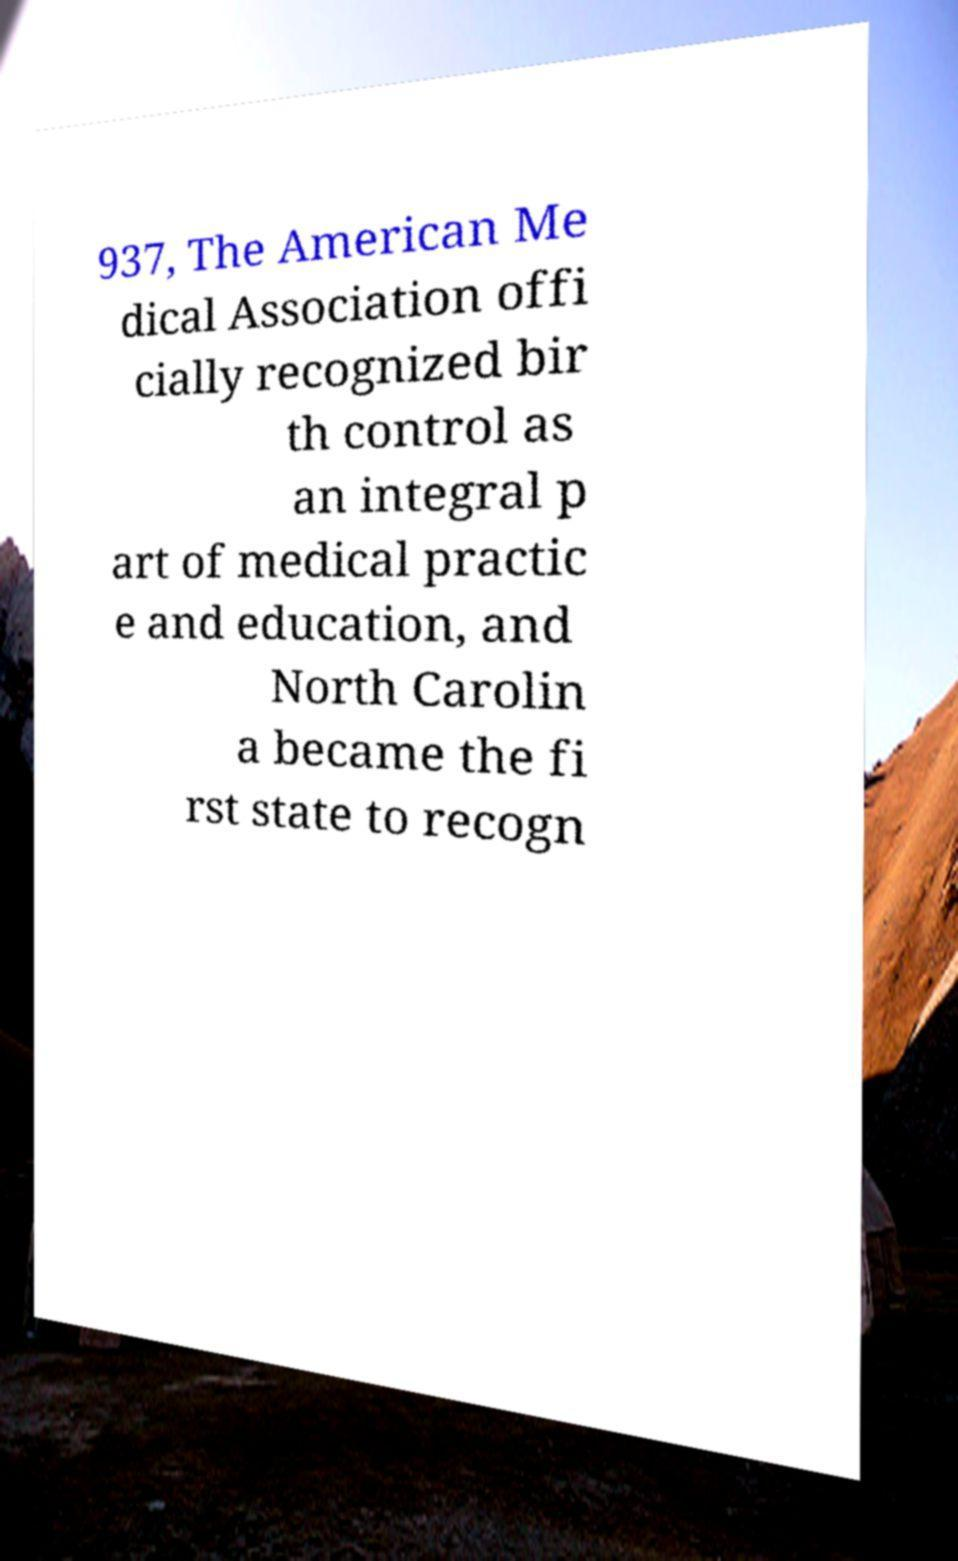Please identify and transcribe the text found in this image. 937, The American Me dical Association offi cially recognized bir th control as an integral p art of medical practic e and education, and North Carolin a became the fi rst state to recogn 